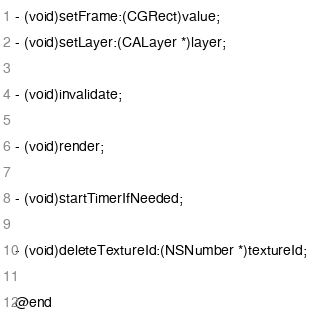Convert code to text. <code><loc_0><loc_0><loc_500><loc_500><_C_>- (void)setFrame:(CGRect)value;
- (void)setLayer:(CALayer *)layer;

- (void)invalidate;

- (void)render;

- (void)startTimerIfNeeded;

- (void)deleteTextureId:(NSNumber *)textureId;

@end
</code> 